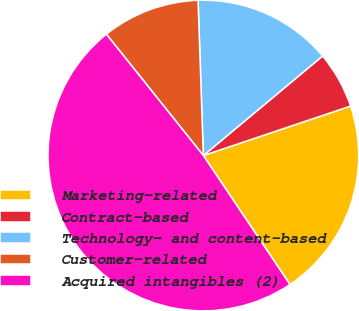<chart> <loc_0><loc_0><loc_500><loc_500><pie_chart><fcel>Marketing-related<fcel>Contract-based<fcel>Technology- and content-based<fcel>Customer-related<fcel>Acquired intangibles (2)<nl><fcel>20.75%<fcel>5.91%<fcel>14.47%<fcel>10.19%<fcel>48.69%<nl></chart> 